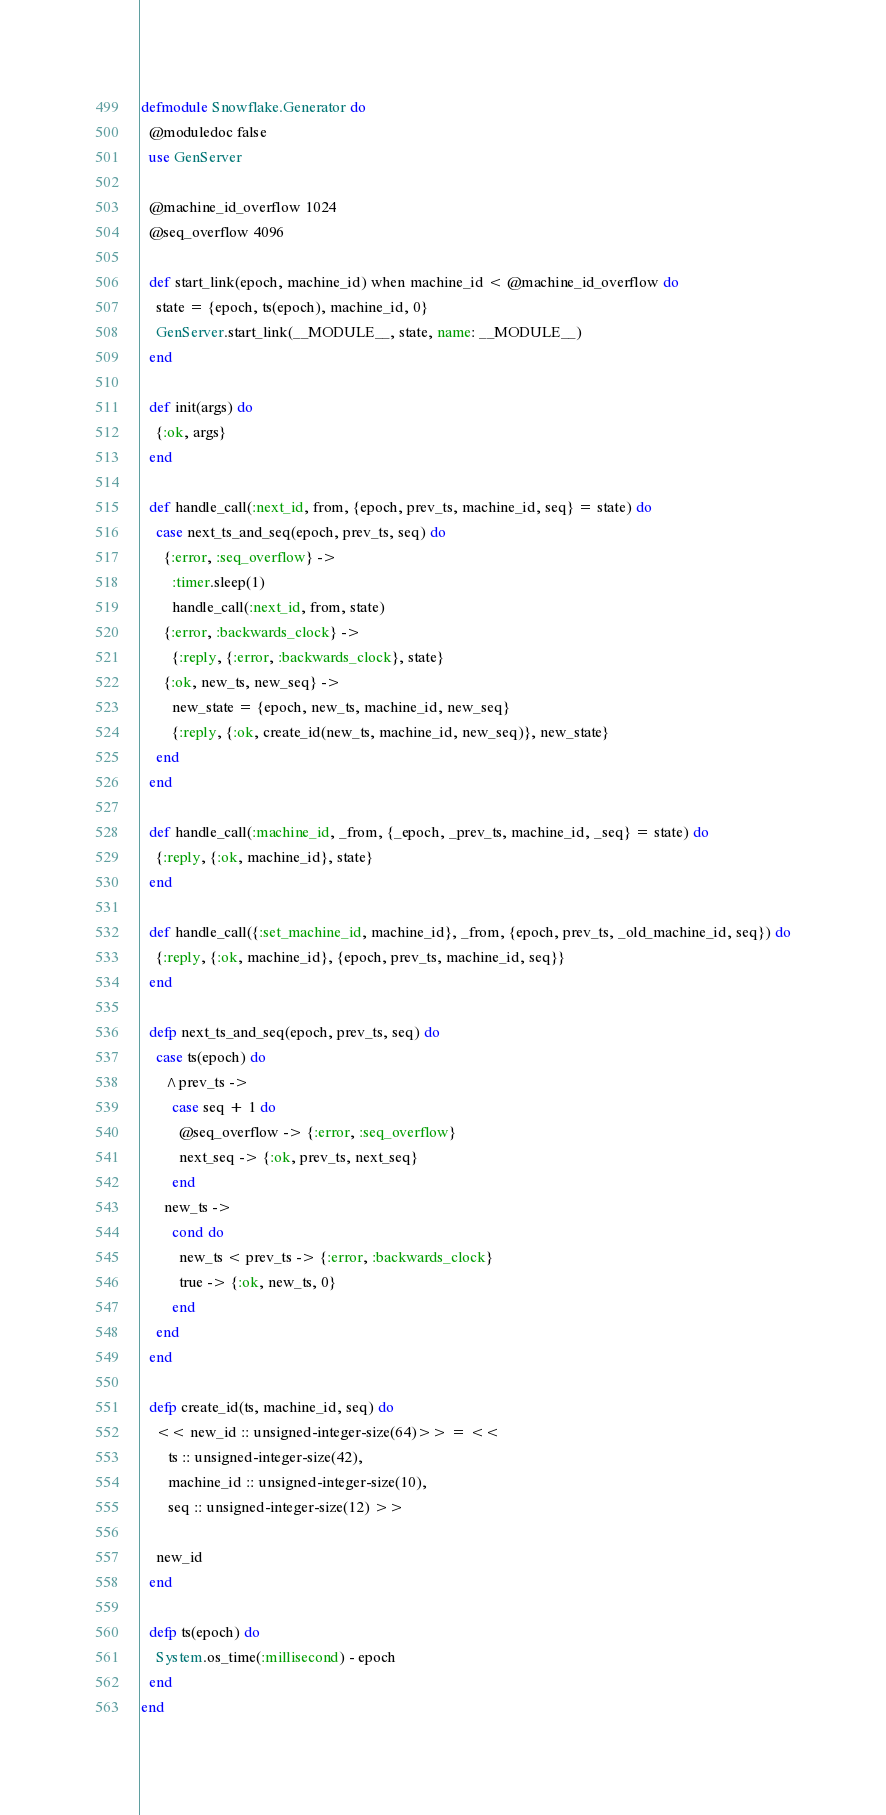Convert code to text. <code><loc_0><loc_0><loc_500><loc_500><_Elixir_>defmodule Snowflake.Generator do
  @moduledoc false
  use GenServer

  @machine_id_overflow 1024
  @seq_overflow 4096

  def start_link(epoch, machine_id) when machine_id < @machine_id_overflow do
    state = {epoch, ts(epoch), machine_id, 0}
    GenServer.start_link(__MODULE__, state, name: __MODULE__)
  end

  def init(args) do
    {:ok, args}
  end

  def handle_call(:next_id, from, {epoch, prev_ts, machine_id, seq} = state) do
    case next_ts_and_seq(epoch, prev_ts, seq) do
      {:error, :seq_overflow} ->
        :timer.sleep(1)
        handle_call(:next_id, from, state)
      {:error, :backwards_clock} ->
        {:reply, {:error, :backwards_clock}, state}
      {:ok, new_ts, new_seq} ->
        new_state = {epoch, new_ts, machine_id, new_seq}
        {:reply, {:ok, create_id(new_ts, machine_id, new_seq)}, new_state}
    end
  end

  def handle_call(:machine_id, _from, {_epoch, _prev_ts, machine_id, _seq} = state) do
    {:reply, {:ok, machine_id}, state}
  end

  def handle_call({:set_machine_id, machine_id}, _from, {epoch, prev_ts, _old_machine_id, seq}) do
    {:reply, {:ok, machine_id}, {epoch, prev_ts, machine_id, seq}}
  end

  defp next_ts_and_seq(epoch, prev_ts, seq) do
    case ts(epoch) do
      ^prev_ts ->
        case seq + 1 do
          @seq_overflow -> {:error, :seq_overflow}
          next_seq -> {:ok, prev_ts, next_seq}
        end
      new_ts ->
        cond do
          new_ts < prev_ts -> {:error, :backwards_clock}
          true -> {:ok, new_ts, 0}
        end
    end
  end

  defp create_id(ts, machine_id, seq) do
    << new_id :: unsigned-integer-size(64)>> = <<
       ts :: unsigned-integer-size(42),
       machine_id :: unsigned-integer-size(10),
       seq :: unsigned-integer-size(12) >>

    new_id
  end

  defp ts(epoch) do
    System.os_time(:millisecond) - epoch
  end
end
</code> 